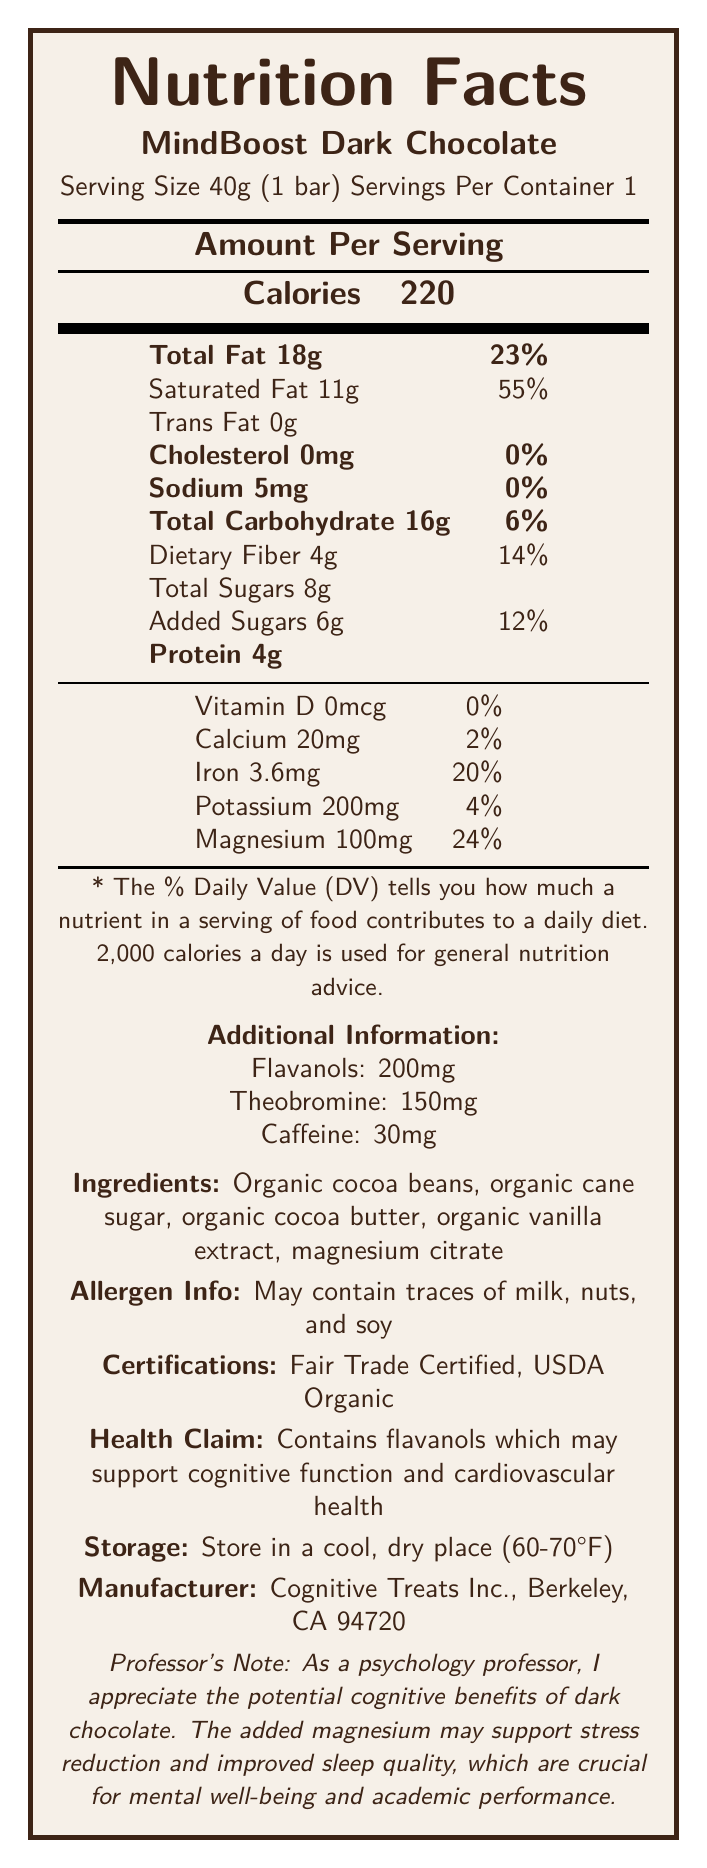What is the serving size of MindBoost Dark Chocolate? The document states that the serving size is 40g, which is equivalent to 1 bar.
Answer: 40g (1 bar) How many calories are in one serving of MindBoost Dark Chocolate? The document lists the calories per serving as 220.
Answer: 220 calories What percentage of the daily value for magnesium does one serving of MindBoost Dark Chocolate provide? According to the document, one serving provides 100mg of magnesium, which is 24% of the daily value.
Answer: 24% What is the amount of total sugars in one serving? The document specifies that the total sugars in one serving are 8g.
Answer: 8g Does the MindBoost Dark Chocolate contain any trans fat? The document indicates that it has 0g of trans fat.
Answer: No Which nutrient does MindBoost Dark Chocolate provide the highest daily value percentage of? A. Vitamin D B. Calcium C. Iron D. Magnesium The document shows that magnesium provides 24% of the daily value, which is the highest among the listed nutrients.
Answer: D What certification does the MindBoost Dark Chocolate have? A. Fair Trade Certified B. USDA Organic C. Both D. None The document states that the chocolate is both Fair Trade Certified and USDA Organic.
Answer: C Which ingredient is not listed in MindBoost Dark Chocolate? A. Organic cocoa beans B. Organic cane sugar C. Sunflower lecithin D. Organic vanilla extract The ingredient list does not mention sunflower lecithin.
Answer: C Does the MindBoost Dark Chocolate contain any artificial additives? The document lists only organic and natural ingredients, with no mention of artificial additives.
Answer: No Summarize the main nutritional values and features of MindBoost Dark Chocolate. This summary captures the essential nutritional values, additional active ingredients, certifications, and potential health benefits mentioned in the document.
Answer: MindBoost Dark Chocolate contains 220 calories per 40g serving, with 18g of total fat, 11g of saturated fat, 0g of trans fat, 5mg of sodium, 16g of total carbohydrates including 4g of dietary fiber and 8g of total sugars (6g added), and 4g of protein. It provides notable amounts of magnesium (24% DV), iron (20% DV), potassium (4% DV), and calcium (2% DV). The chocolate has added flavanols, theobromine, and caffeine. It is organic, Fair Trade Certified, and may support cognitive function and cardiovascular health. How much protein is in one serving of MindBoost Dark Chocolate? The document specifies that one serving contains 4 grams of protein.
Answer: 4g What company manufactures MindBoost Dark Chocolate? The document identifies Cognitive Treats Inc., located in Berkeley, CA, as the manufacturer.
Answer: Cognitive Treats Inc. What is the specific health claim made about MindBoost Dark Chocolate? The document states that the chocolate contains flavanols which may support cognitive function and cardiovascular health.
Answer: Contains flavanols which may support cognitive function and cardiovascular health. Is the chocolate suitable for individuals with dairy allergies? The document mentions that it may contain traces of milk, so it might not be suitable for people with dairy allergies.
Answer: May not be safe Which nutrient provides the least percentage of daily value in MindBoost Dark Chocolate? The document shows that Vitamin D provides 0% of the daily value.
Answer: Vitamin D How many servings are there in one container of MindBoost Dark Chocolate? The document states that there is one serving per container.
Answer: 1 Does MindBoost Dark Chocolate contain high levels of sodium? The document shows that there are only 5mg of sodium, which is 0% of the daily value, indicating low sodium content.
Answer: No What is the recommended storage condition for MindBoost Dark Chocolate? The document advises storing it in a cool, dry place with a temperature range of 60-70°F.
Answer: Store in a cool, dry place (60-70°F) What is the total amount of dietary fiber in one serving of MindBoost Dark Chocolate? A. 2g B. 3g C. 4g D. 5g The document specifies that there are 4 grams of dietary fiber per serving.
Answer: C What additional information is provided about the ingredients of the chocolate? The document mentions that it may contain traces of milk, nuts, and soy in the allergen information section.
Answer: May contain traces of milk, nuts, and soy. 